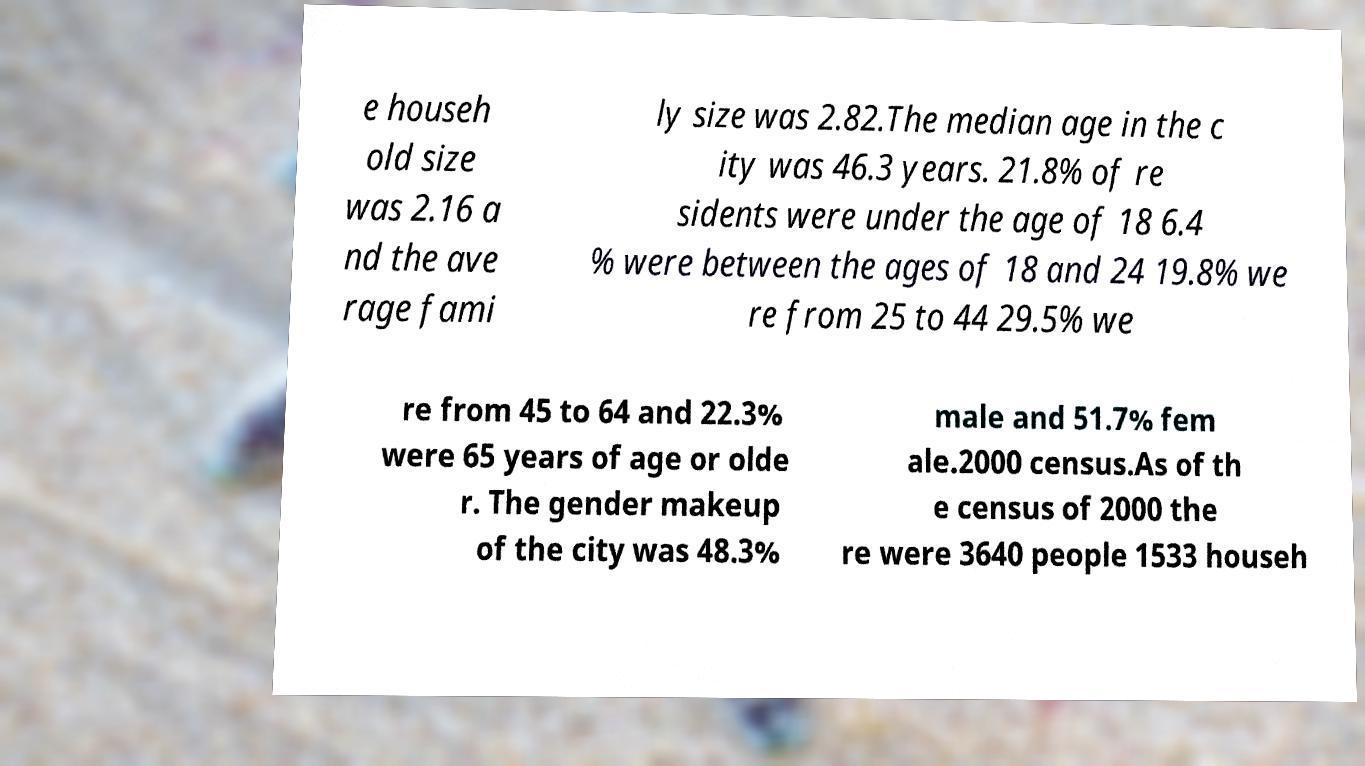Could you extract and type out the text from this image? e househ old size was 2.16 a nd the ave rage fami ly size was 2.82.The median age in the c ity was 46.3 years. 21.8% of re sidents were under the age of 18 6.4 % were between the ages of 18 and 24 19.8% we re from 25 to 44 29.5% we re from 45 to 64 and 22.3% were 65 years of age or olde r. The gender makeup of the city was 48.3% male and 51.7% fem ale.2000 census.As of th e census of 2000 the re were 3640 people 1533 househ 